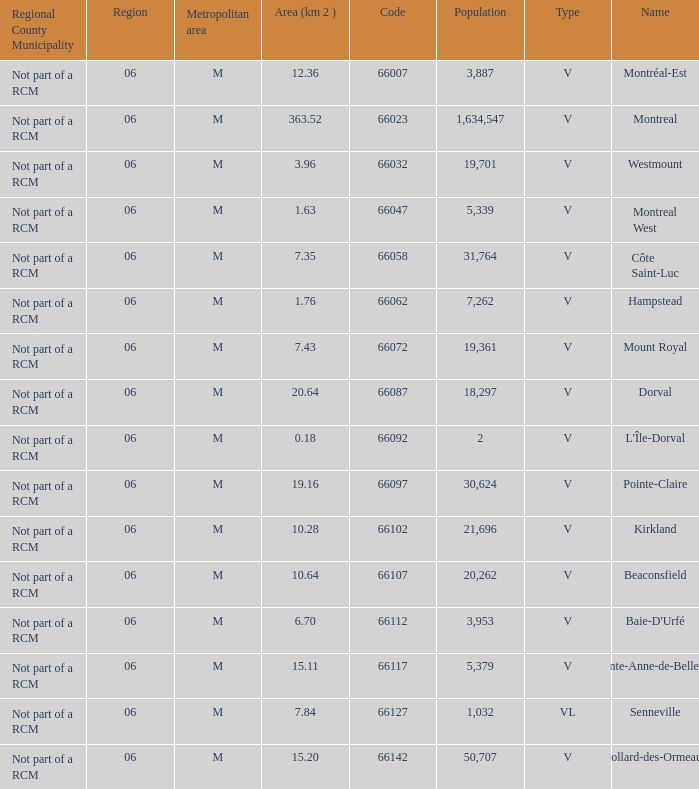What is the largest region with a Code smaller than 66112, and a Name of l'île-dorval? 6.0. 